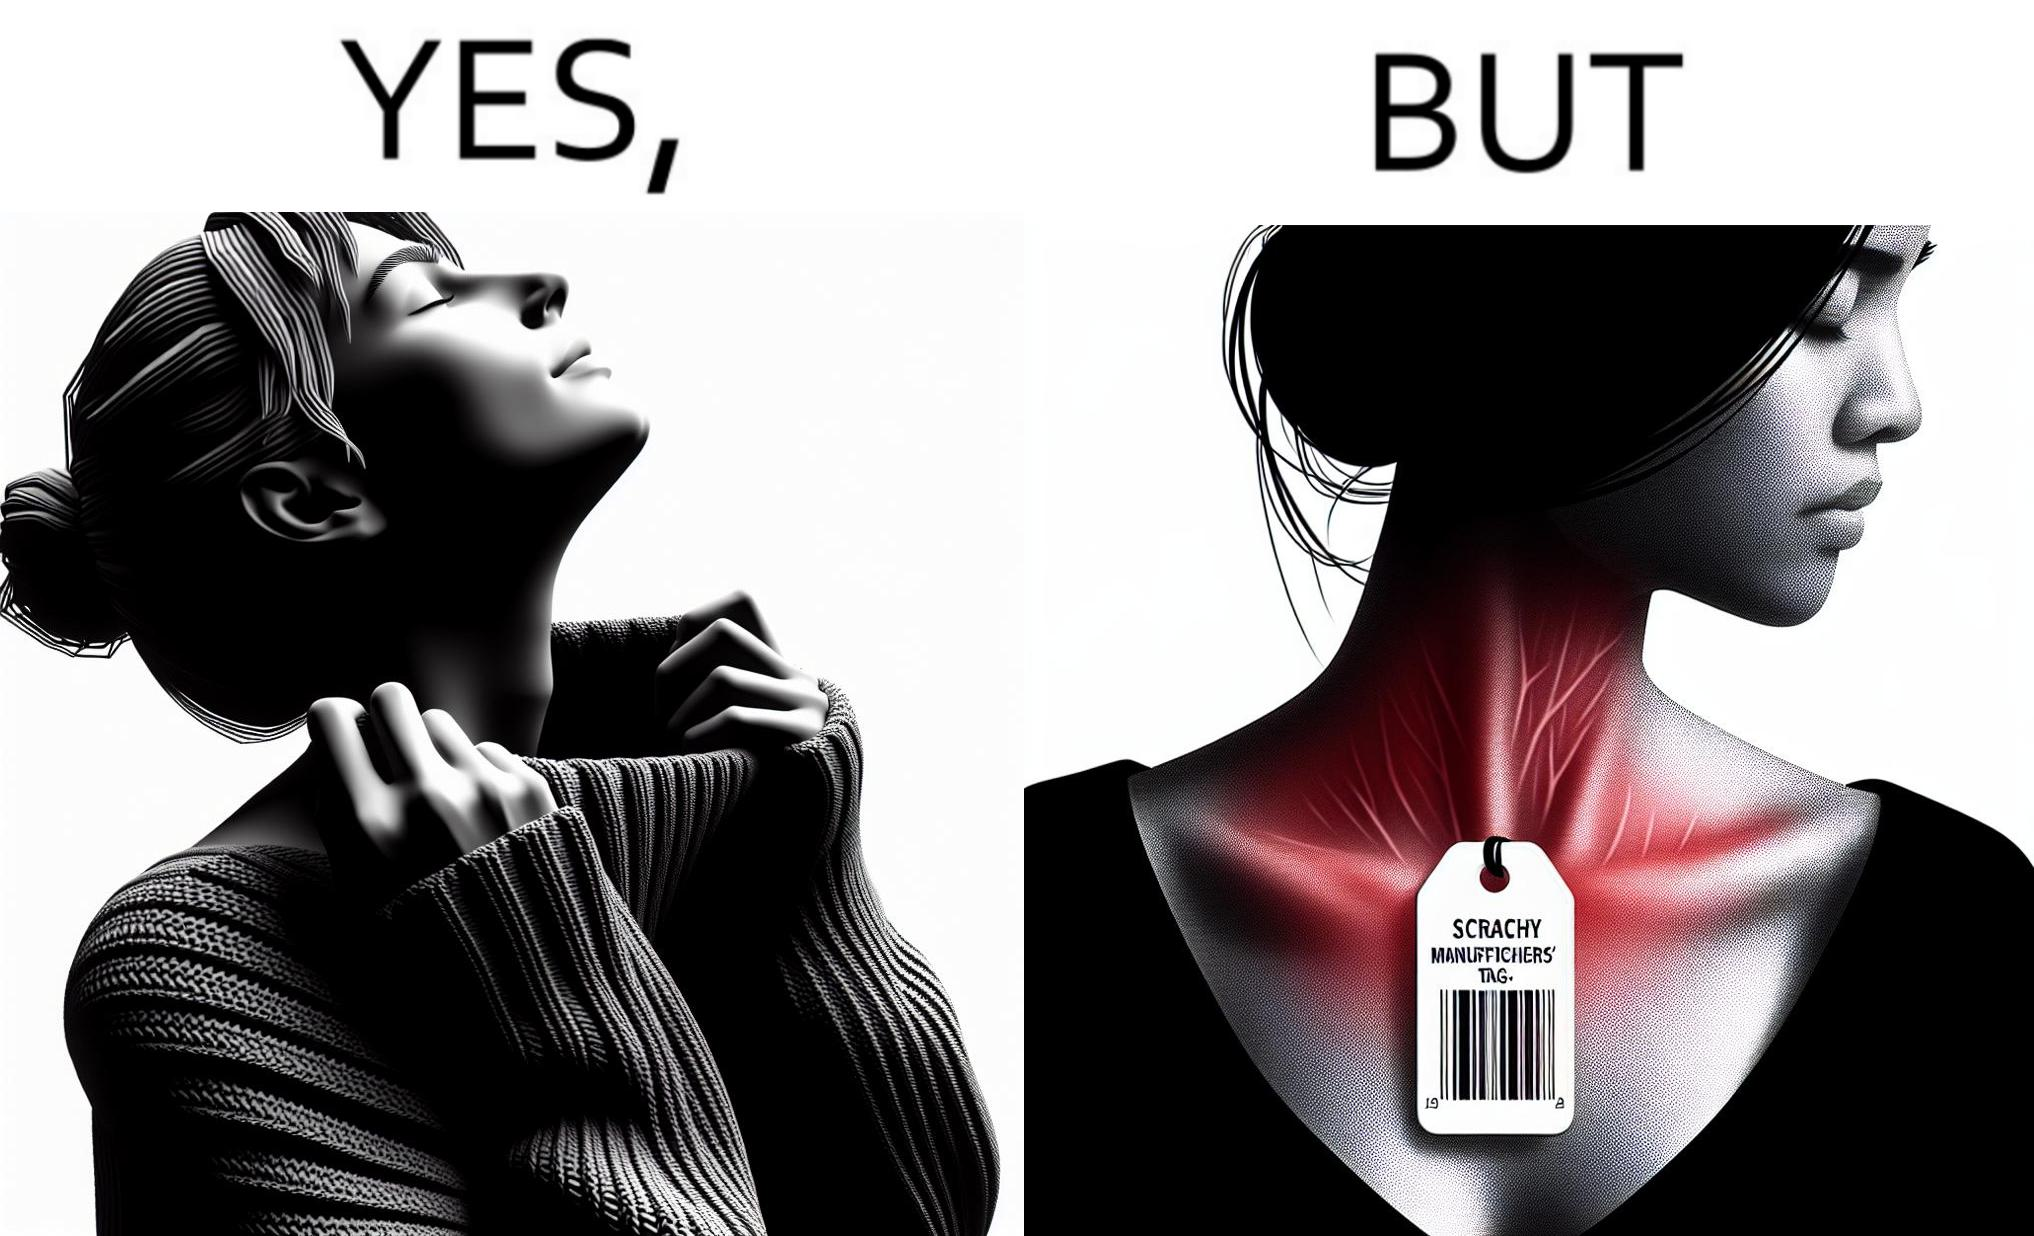Describe what you see in this image. The images are funny since it shows how even though sweaters and other clothings provide much comfort, a tiny manufacturers tag ends up causing the user a lot of discomfort due to constant scratching 